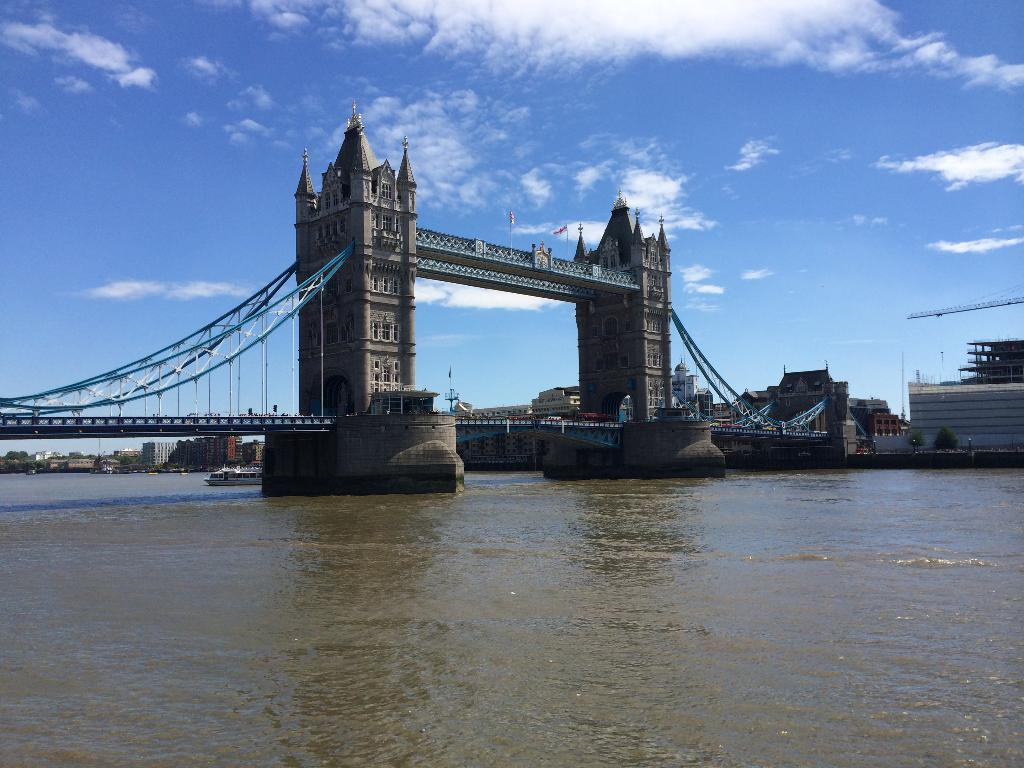What type of structure is present in the image? There is a tower bridge in the image. What is located in the water body near the bridge? There is a ship in the water body. What can be seen supporting the flags in the image? There are poles in the image. What is attached to the poles? The flags are visible in the image. What type of barrier is present in the image? There is a metal fence in the image. What type of vegetation is present in the image? There is a group of trees in the image. What type of man-made structures are present in the image? There are buildings in the image. How would you describe the sky in the image? The sky is visible in the image and appears cloudy. Where is the toothbrush located in the image? There is no toothbrush present in the image. What type of letter can be seen on the ship in the image? There is no letter visible on the ship in the image. 